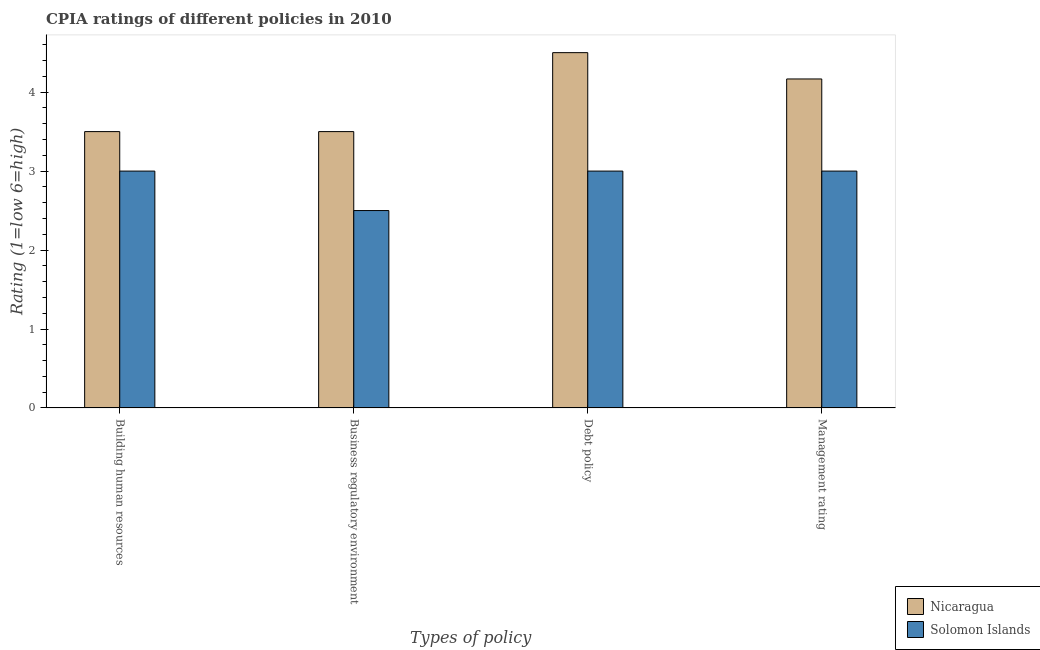How many different coloured bars are there?
Ensure brevity in your answer.  2. How many bars are there on the 1st tick from the right?
Your answer should be very brief. 2. What is the label of the 2nd group of bars from the left?
Offer a terse response. Business regulatory environment. What is the cpia rating of building human resources in Solomon Islands?
Your answer should be compact. 3. Across all countries, what is the maximum cpia rating of management?
Ensure brevity in your answer.  4.17. Across all countries, what is the minimum cpia rating of business regulatory environment?
Provide a succinct answer. 2.5. In which country was the cpia rating of debt policy maximum?
Your answer should be very brief. Nicaragua. In which country was the cpia rating of building human resources minimum?
Make the answer very short. Solomon Islands. What is the difference between the cpia rating of building human resources and cpia rating of management in Solomon Islands?
Your response must be concise. 0. In how many countries, is the cpia rating of debt policy greater than 0.6000000000000001 ?
Make the answer very short. 2. What is the ratio of the cpia rating of building human resources in Solomon Islands to that in Nicaragua?
Keep it short and to the point. 0.86. What is the difference between the highest and the second highest cpia rating of management?
Your answer should be compact. 1.17. Is the sum of the cpia rating of business regulatory environment in Solomon Islands and Nicaragua greater than the maximum cpia rating of debt policy across all countries?
Provide a succinct answer. Yes. Is it the case that in every country, the sum of the cpia rating of business regulatory environment and cpia rating of management is greater than the sum of cpia rating of building human resources and cpia rating of debt policy?
Offer a very short reply. No. What does the 2nd bar from the left in Management rating represents?
Make the answer very short. Solomon Islands. What does the 2nd bar from the right in Management rating represents?
Provide a succinct answer. Nicaragua. Is it the case that in every country, the sum of the cpia rating of building human resources and cpia rating of business regulatory environment is greater than the cpia rating of debt policy?
Make the answer very short. Yes. How many bars are there?
Give a very brief answer. 8. What is the difference between two consecutive major ticks on the Y-axis?
Offer a terse response. 1. Does the graph contain any zero values?
Your answer should be compact. No. Does the graph contain grids?
Your answer should be compact. No. Where does the legend appear in the graph?
Give a very brief answer. Bottom right. What is the title of the graph?
Your answer should be very brief. CPIA ratings of different policies in 2010. What is the label or title of the X-axis?
Your answer should be compact. Types of policy. What is the Rating (1=low 6=high) of Nicaragua in Business regulatory environment?
Give a very brief answer. 3.5. What is the Rating (1=low 6=high) of Nicaragua in Debt policy?
Your answer should be very brief. 4.5. What is the Rating (1=low 6=high) in Solomon Islands in Debt policy?
Offer a very short reply. 3. What is the Rating (1=low 6=high) in Nicaragua in Management rating?
Make the answer very short. 4.17. Across all Types of policy, what is the maximum Rating (1=low 6=high) of Nicaragua?
Offer a very short reply. 4.5. Across all Types of policy, what is the maximum Rating (1=low 6=high) of Solomon Islands?
Offer a very short reply. 3. What is the total Rating (1=low 6=high) in Nicaragua in the graph?
Provide a succinct answer. 15.67. What is the total Rating (1=low 6=high) of Solomon Islands in the graph?
Make the answer very short. 11.5. What is the difference between the Rating (1=low 6=high) in Nicaragua in Building human resources and that in Business regulatory environment?
Provide a succinct answer. 0. What is the difference between the Rating (1=low 6=high) in Nicaragua in Building human resources and that in Management rating?
Your answer should be compact. -0.67. What is the difference between the Rating (1=low 6=high) of Solomon Islands in Building human resources and that in Management rating?
Ensure brevity in your answer.  0. What is the difference between the Rating (1=low 6=high) in Nicaragua in Business regulatory environment and that in Debt policy?
Keep it short and to the point. -1. What is the difference between the Rating (1=low 6=high) of Solomon Islands in Business regulatory environment and that in Debt policy?
Make the answer very short. -0.5. What is the difference between the Rating (1=low 6=high) in Nicaragua in Business regulatory environment and that in Management rating?
Ensure brevity in your answer.  -0.67. What is the difference between the Rating (1=low 6=high) in Solomon Islands in Debt policy and that in Management rating?
Your answer should be compact. 0. What is the difference between the Rating (1=low 6=high) in Nicaragua in Debt policy and the Rating (1=low 6=high) in Solomon Islands in Management rating?
Keep it short and to the point. 1.5. What is the average Rating (1=low 6=high) in Nicaragua per Types of policy?
Your answer should be very brief. 3.92. What is the average Rating (1=low 6=high) of Solomon Islands per Types of policy?
Your answer should be compact. 2.88. What is the difference between the Rating (1=low 6=high) in Nicaragua and Rating (1=low 6=high) in Solomon Islands in Building human resources?
Keep it short and to the point. 0.5. What is the difference between the Rating (1=low 6=high) of Nicaragua and Rating (1=low 6=high) of Solomon Islands in Business regulatory environment?
Give a very brief answer. 1. What is the difference between the Rating (1=low 6=high) of Nicaragua and Rating (1=low 6=high) of Solomon Islands in Debt policy?
Offer a very short reply. 1.5. What is the ratio of the Rating (1=low 6=high) of Nicaragua in Building human resources to that in Business regulatory environment?
Give a very brief answer. 1. What is the ratio of the Rating (1=low 6=high) in Nicaragua in Building human resources to that in Debt policy?
Keep it short and to the point. 0.78. What is the ratio of the Rating (1=low 6=high) in Nicaragua in Building human resources to that in Management rating?
Offer a very short reply. 0.84. What is the ratio of the Rating (1=low 6=high) in Nicaragua in Business regulatory environment to that in Debt policy?
Ensure brevity in your answer.  0.78. What is the ratio of the Rating (1=low 6=high) in Solomon Islands in Business regulatory environment to that in Debt policy?
Your response must be concise. 0.83. What is the ratio of the Rating (1=low 6=high) of Nicaragua in Business regulatory environment to that in Management rating?
Ensure brevity in your answer.  0.84. What is the difference between the highest and the second highest Rating (1=low 6=high) of Solomon Islands?
Provide a succinct answer. 0. What is the difference between the highest and the lowest Rating (1=low 6=high) in Solomon Islands?
Keep it short and to the point. 0.5. 